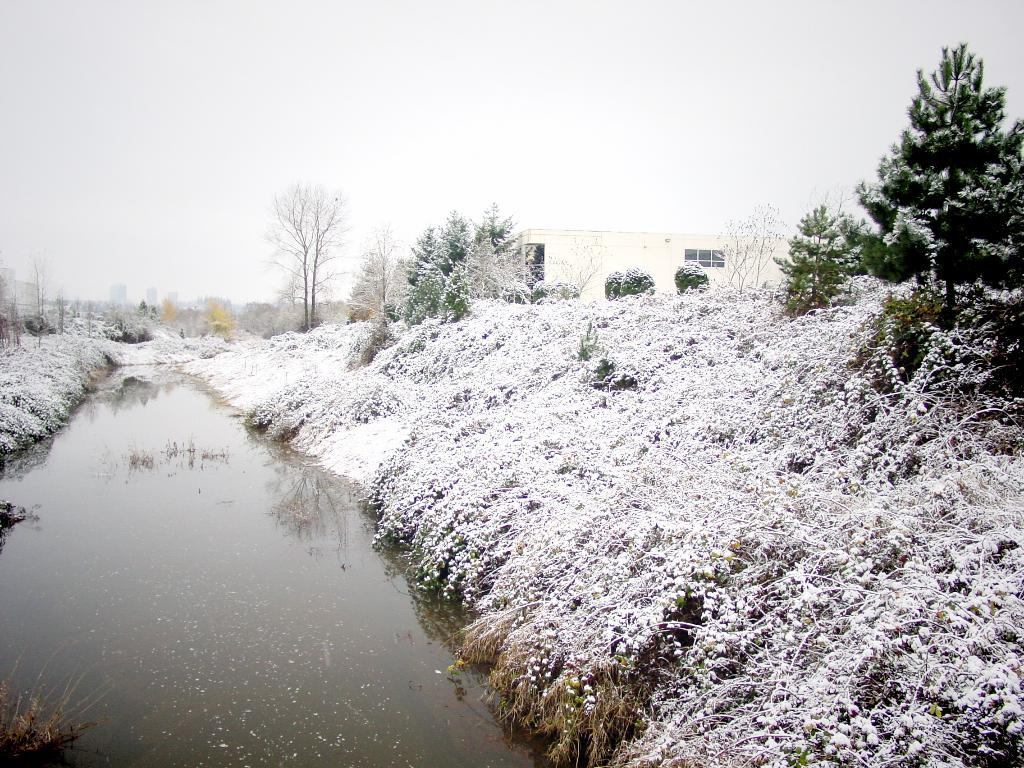What natural element is present in the image? There is water in the image. What type of weather condition is depicted in the image? There is snow in the image. What type of vegetation is visible in the image? There are trees in the image. What type of structure is present in the image? There is a building in the image. What is visible in the background of the image? The sky is visible in the background of the image. What type of club can be seen in the image? There is no club present in the image. What song is being played in the background of the image? There is no song playing in the background of the image. 